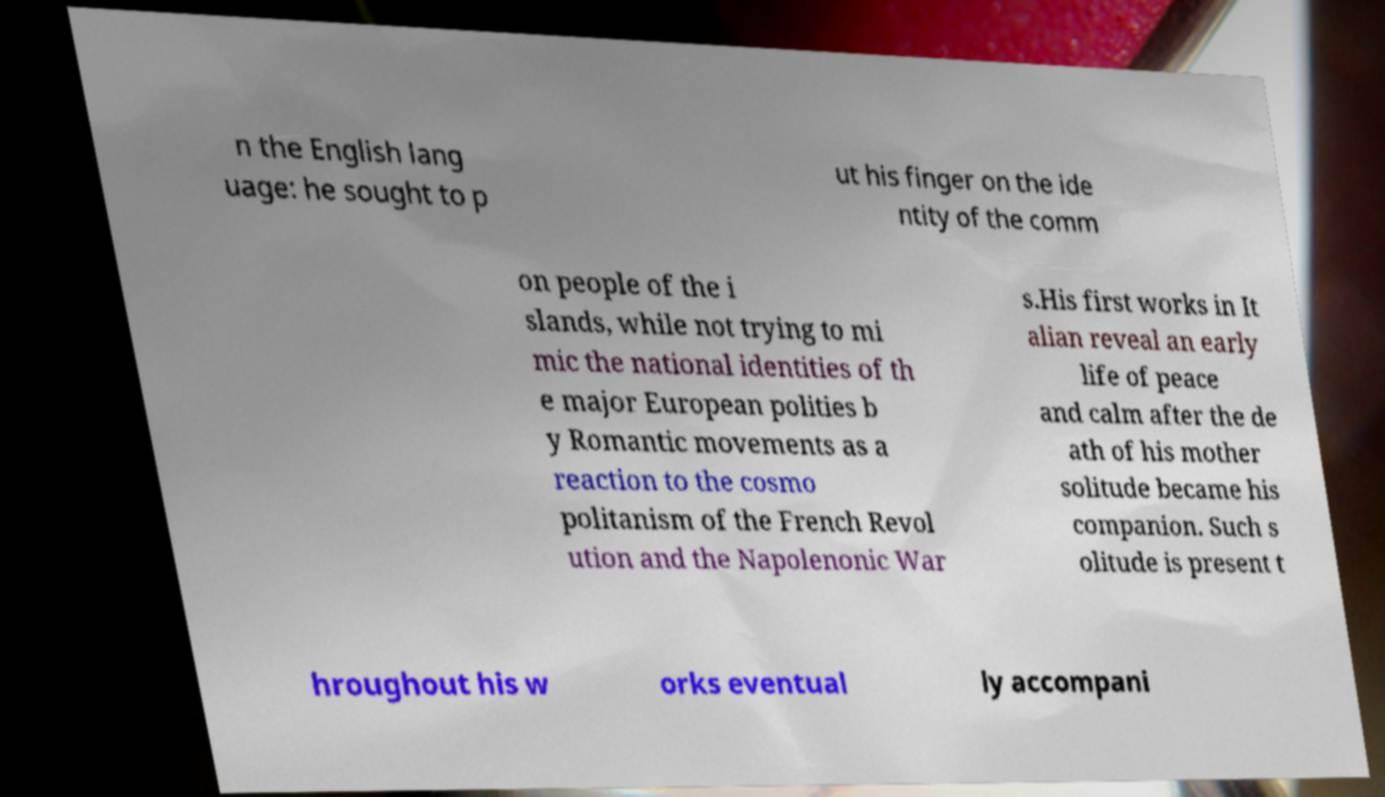Please read and relay the text visible in this image. What does it say? n the English lang uage: he sought to p ut his finger on the ide ntity of the comm on people of the i slands, while not trying to mi mic the national identities of th e major European polities b y Romantic movements as a reaction to the cosmo politanism of the French Revol ution and the Napolenonic War s.His first works in It alian reveal an early life of peace and calm after the de ath of his mother solitude became his companion. Such s olitude is present t hroughout his w orks eventual ly accompani 